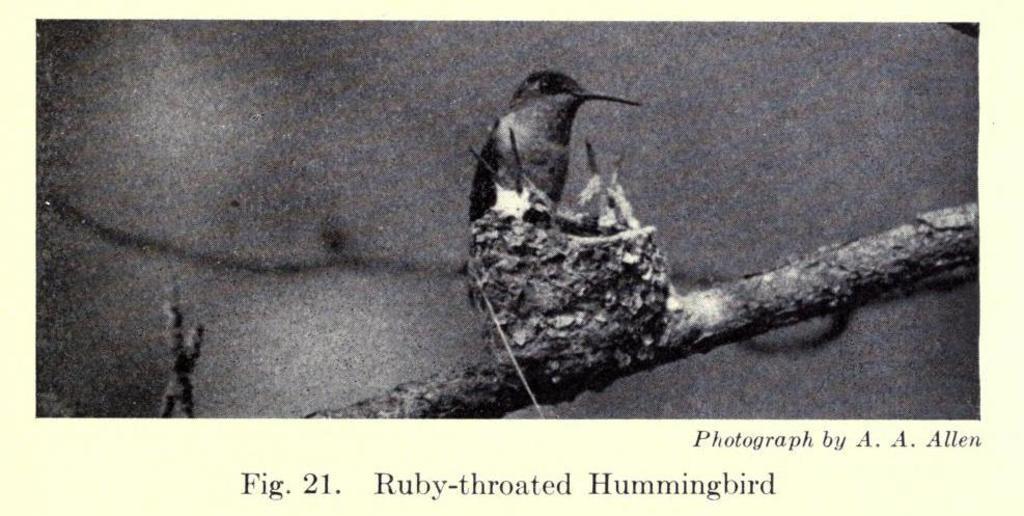In one or two sentences, can you explain what this image depicts? In this picture we can see an image of a bird on the paper and the bird is on the branch. On the paper it is written something. 